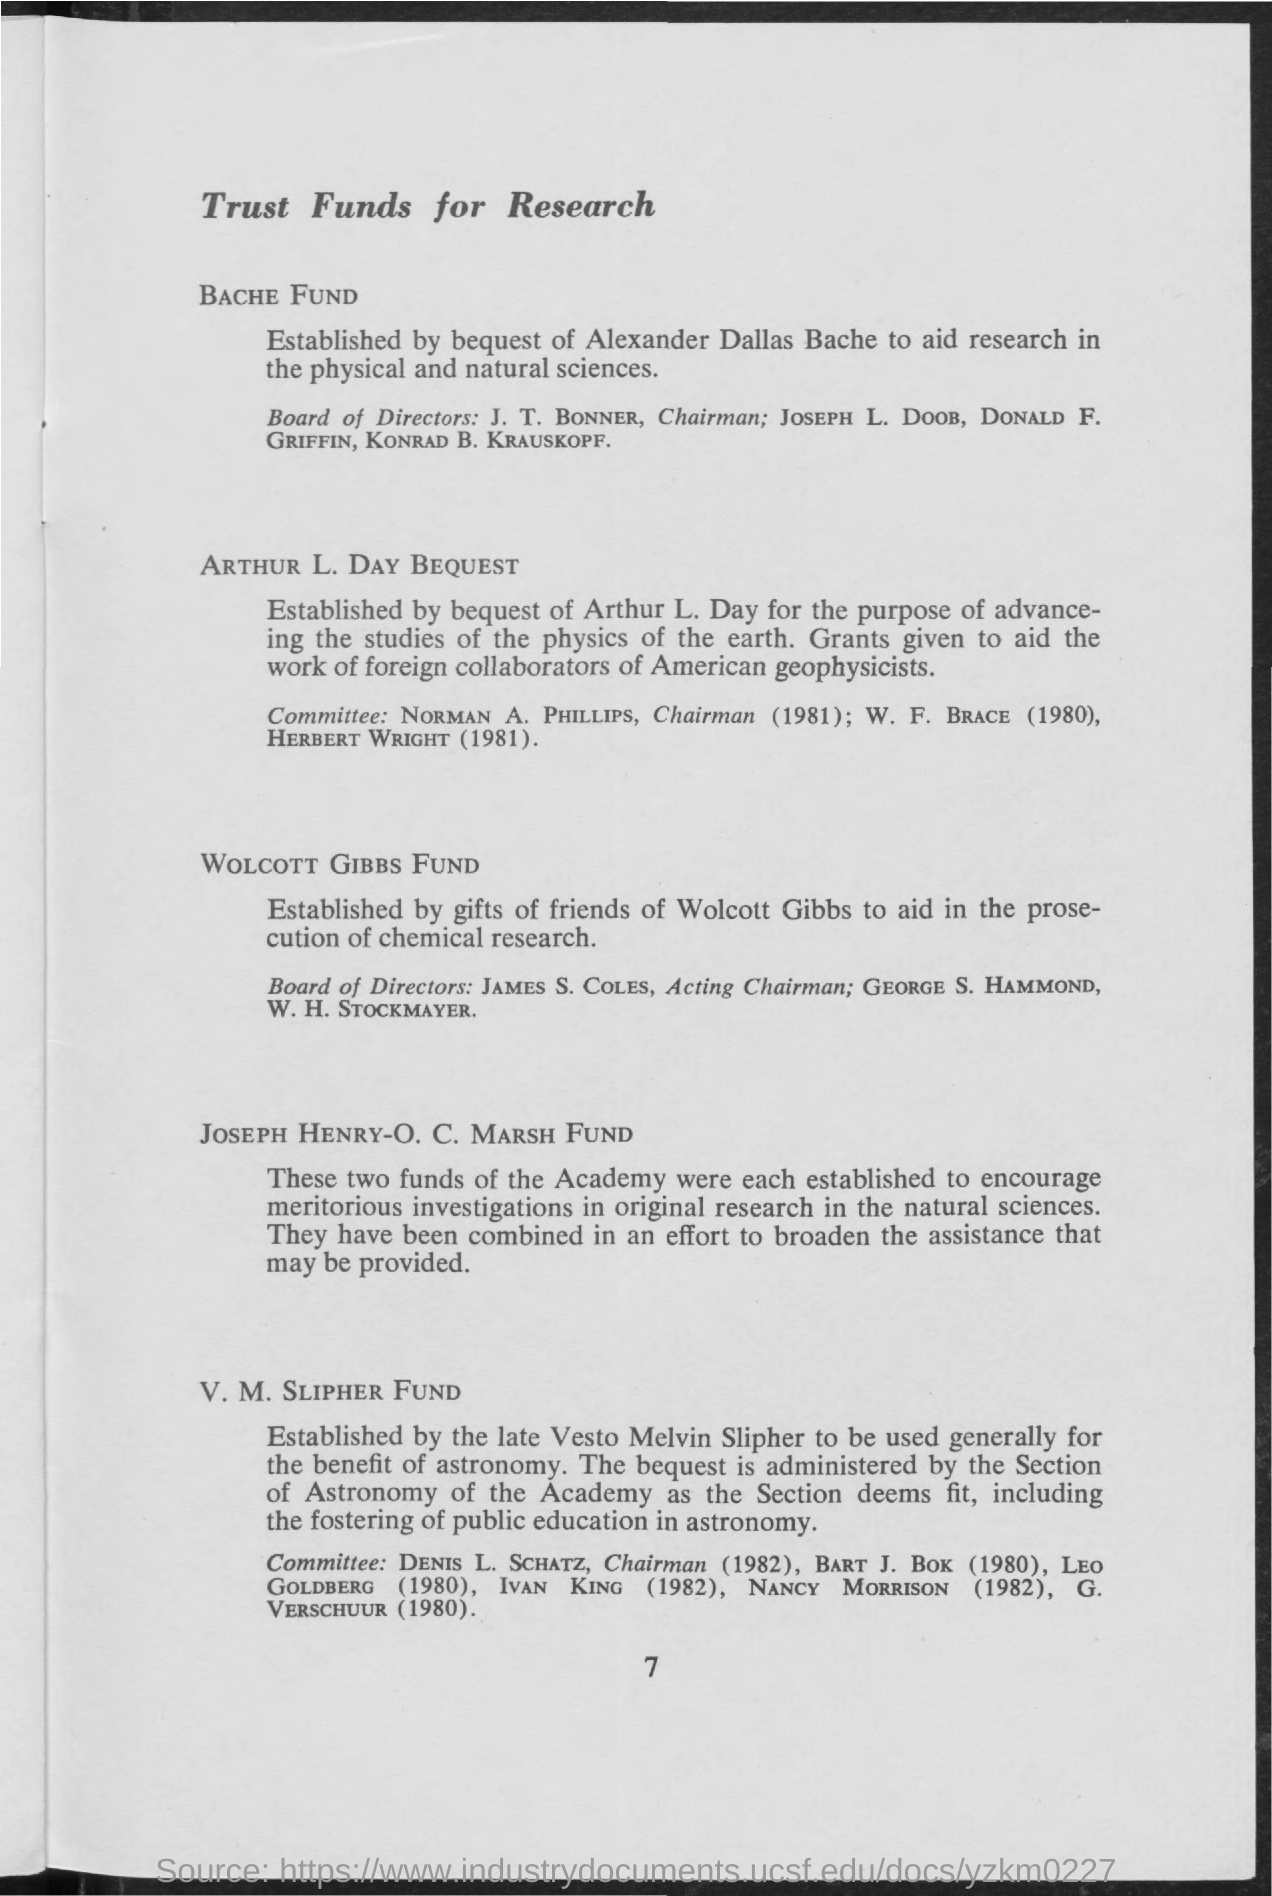Give some essential details in this illustration. The number 7 is referred to as a page number. 